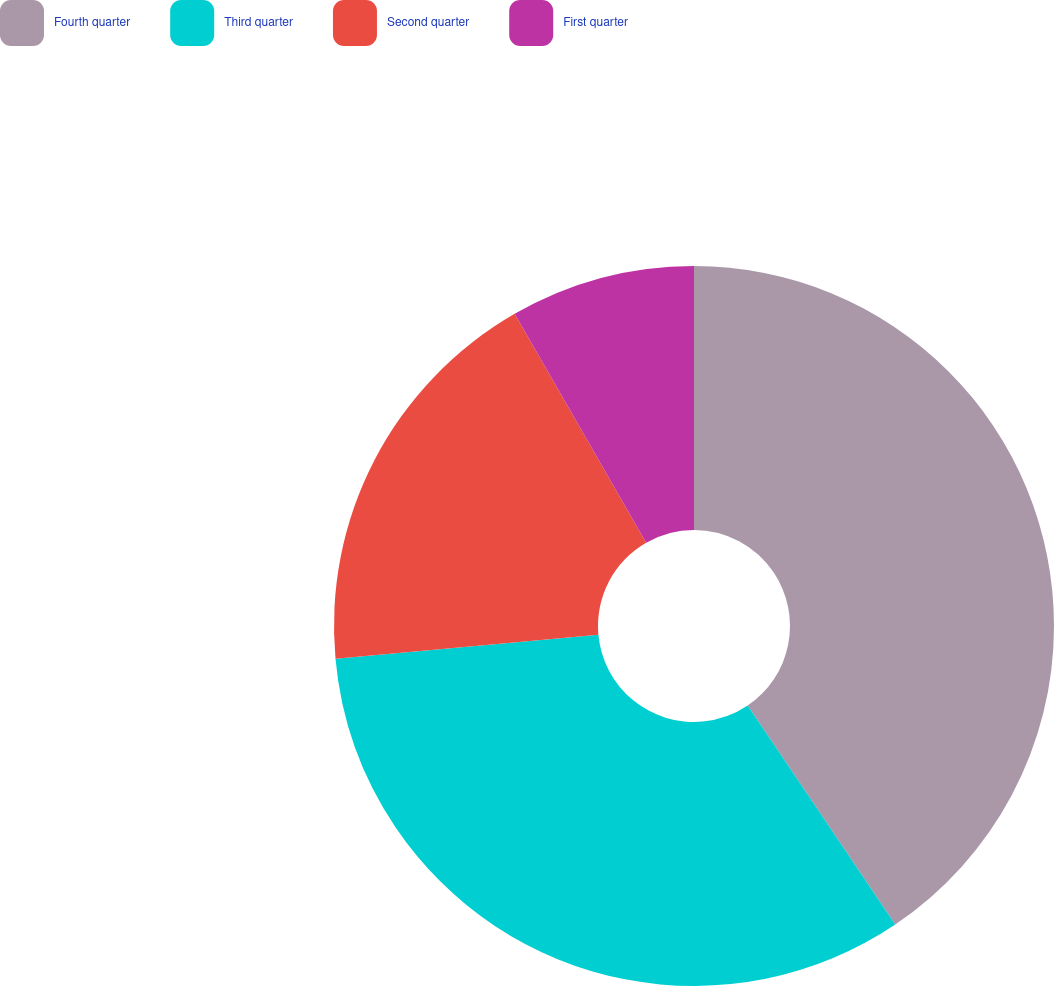Convert chart. <chart><loc_0><loc_0><loc_500><loc_500><pie_chart><fcel>Fourth quarter<fcel>Third quarter<fcel>Second quarter<fcel>First quarter<nl><fcel>40.56%<fcel>32.99%<fcel>18.15%<fcel>8.3%<nl></chart> 